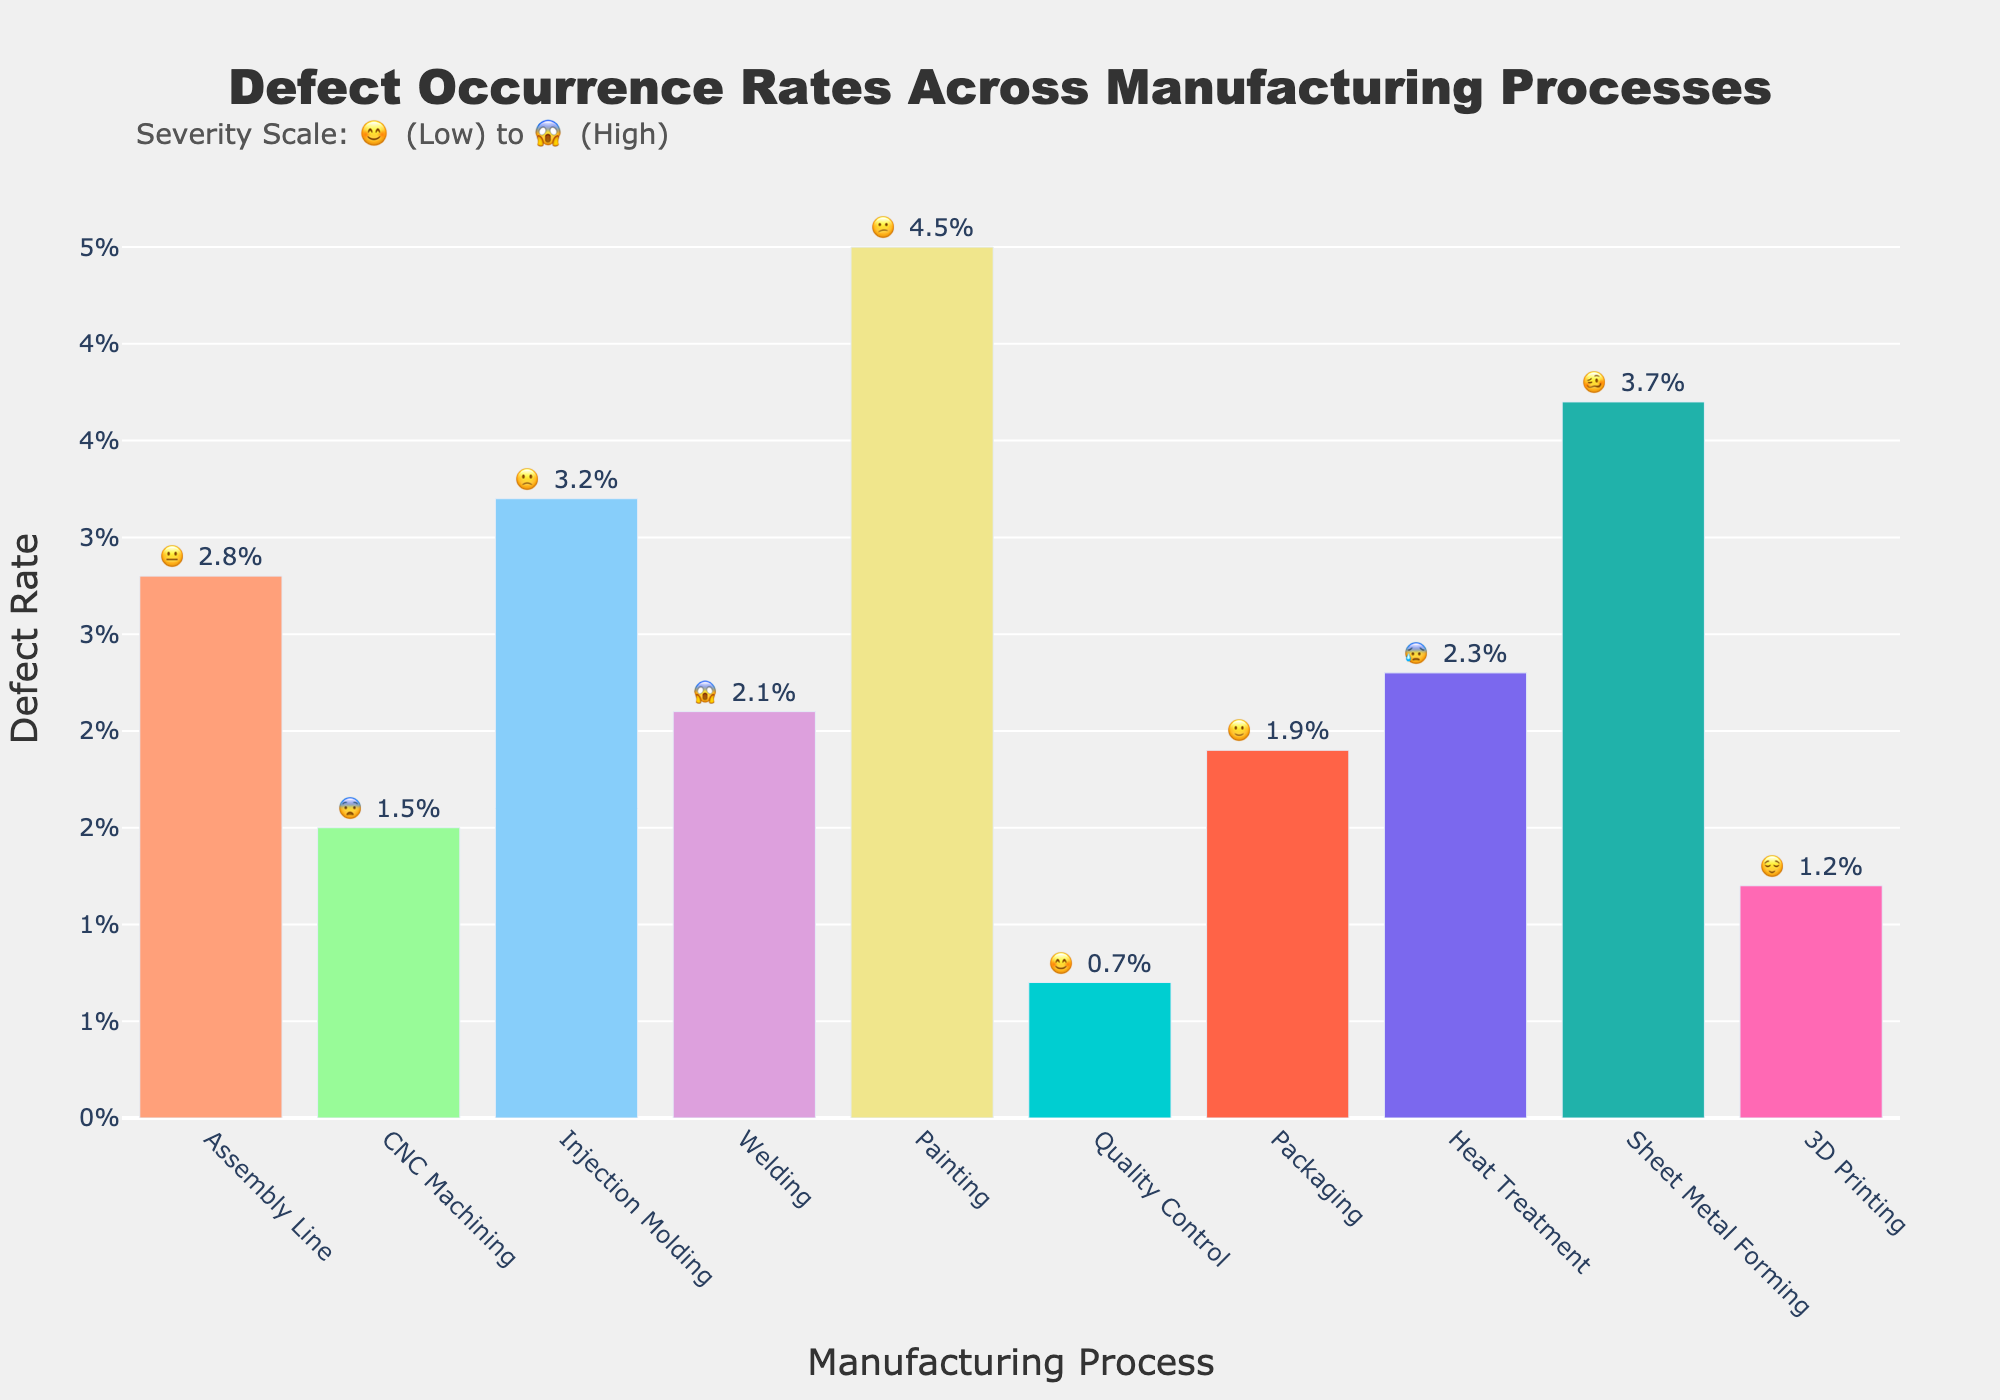What is the title of the figure? The title of the figure is located at the top and centered for easy identification. It clearly states the main subject of the figure, which is defect occurrence rates across various manufacturing processes.
Answer: Defect Occurrence Rates Across Manufacturing Processes Which manufacturing process has the highest defect rate? By examining the length of the bars, the process with the highest defect rate is easily identifiable as the bar that reaches the highest point on the y-axis.
Answer: Painting What is the defect rate of CNC Machining? Looking at the bar labeled CNC Machining and reading the value annotated above it, we can determine the defect rate.
Answer: 1.5% Among the processes with defect rates above 3%, which has the lowest severity emoji? Identify processes with defect rates above 3%, which are Injection Molding, Painting, and Sheet Metal Forming. Out of these, Injection Molding has 😕, which indicates a lower severity compared to 😕 and 🥴.
Answer: Injection Molding How many processes have a defect rate below 2%? By counting the number of bars that don't exceed the 2% mark on the y-axis, we can get the total number of processes with low defect rates. These processes are CNC Machining, Quality Control, 3D Printing, and Packaging.
Answer: 4 What is the average defect rate across all manufacturing processes? To find the average defect rate, add all the defect rates and divide by the number of processes: (2.8% + 1.5% + 3.2% + 2.1% + 4.5% + 0.7% + 1.9% + 2.3% + 3.7% + 1.2%) / 10 = 2.39%
Answer: 2.39% Which manufacturing process has the least severe defect rate and what is its severity emoji? By comparing the severity emojis, find the one with a smiley face, indicating lower severity. Quality Control has a 😊 emoji.
Answer: Quality Control 😌 How does the defect rate of Welding compare to Heat Treatment? Evaluate the lengths of the bars for Welding and Heat Treatment and compare their values. Welding has a 2.1% defect rate while Heat Treatment has 2.3%.
Answer: Welding is lower What can you infer about the process with a defect rate of 4.5% based on its emoji? Look at the emoji associated with the Painting process (4.5%), which is 😕, indicating a moderately high concern level.
Answer: Moderately high concern 